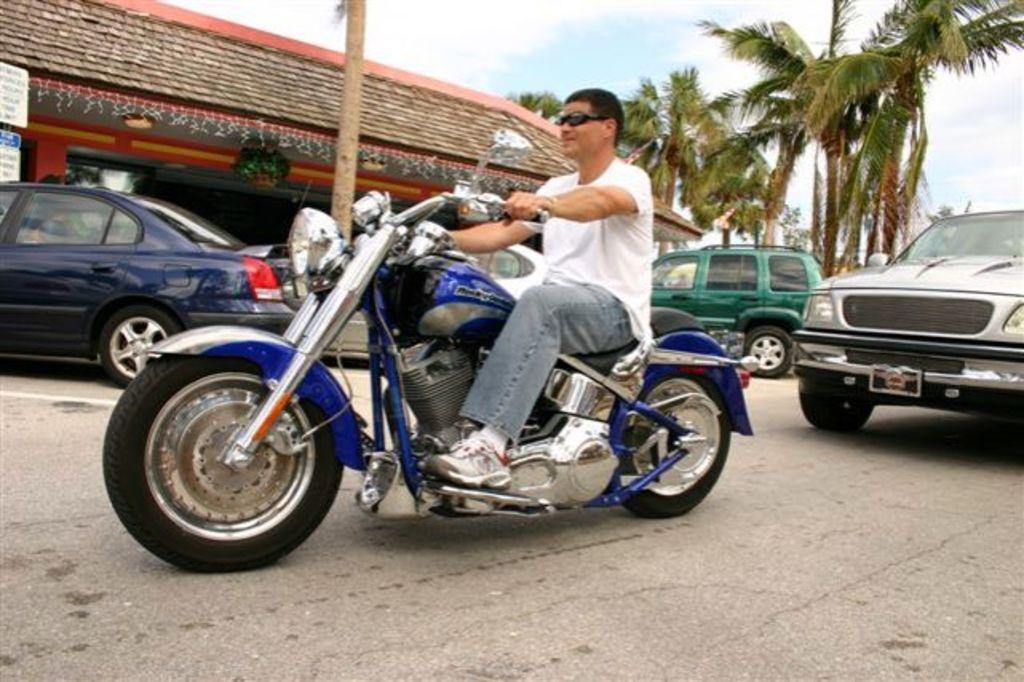Could you give a brief overview of what you see in this image? here in this picture we can see the person sitting on the motor cycle,here we can also see the cars on the road,here we can also see trees and a house near to the road,here we can see the clear sky. 